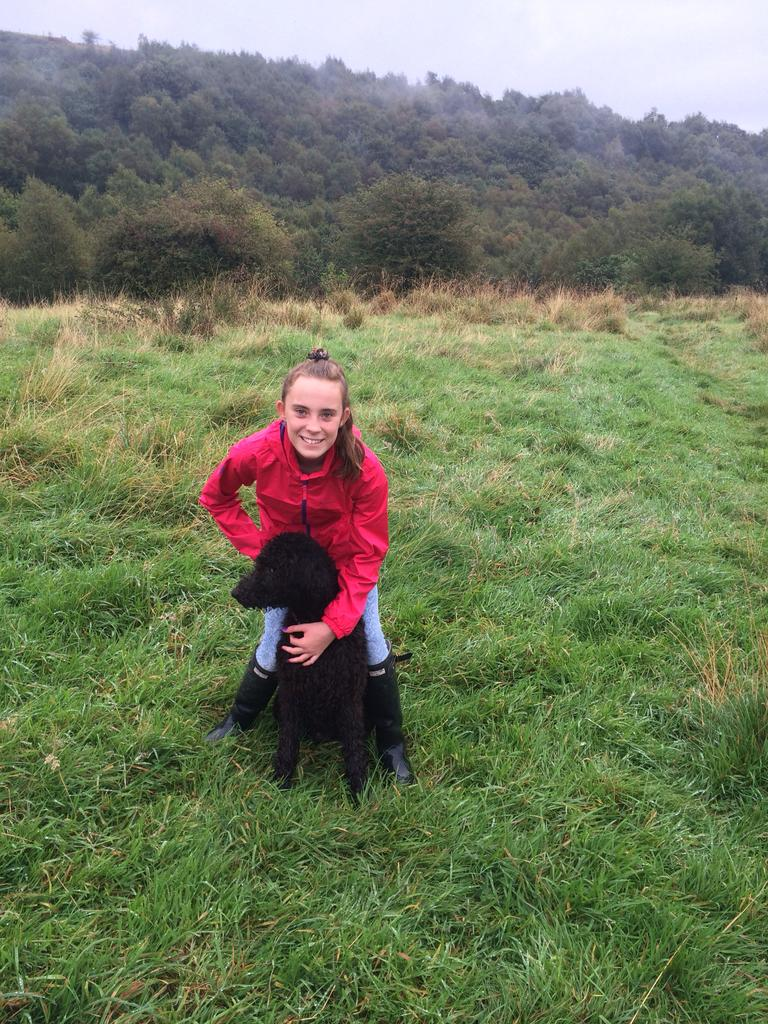What is the person in the image doing? The person is sitting in the image. What is the person holding in the image? The person is holding an animal. What is the emotional state of the person in the image? The person is smiling. What can be seen in the background of the image? Trees and sky are visible in the background of the image. What type of ground surface is present in the image? There is grass in the image. What type of war is being depicted in the image? There is no war depicted in the image; it features a person sitting and holding an animal. What kind of stamp can be seen on the person's forehead in the image? There is no stamp present on the person's forehead in the image. 